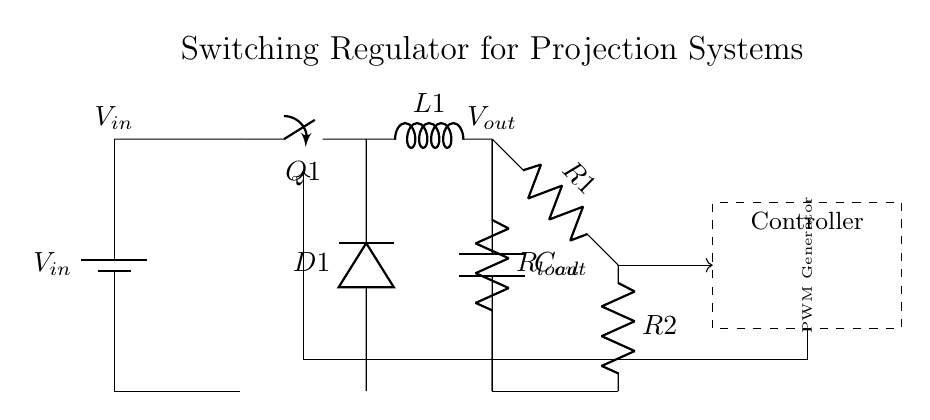What is the input voltage of the circuit? The input voltage is indicated as V_in at the top left of the diagram. It's typically connected to a battery or power supply which provides the voltage for the circuit.
Answer: V_in What type of switch is used in this circuit? The switch is labeled as Q1 in the diagram. Given the context of a switching regulator, it is typically a MOSFET or transistor used to control the flow of current through the inductor.
Answer: Q1 What component is responsible for smoothing the output voltage? The output capacitor is labeled C_out. It works by filtering the voltage ripple caused by switching, providing a steadier output voltage to the load.
Answer: C_out Explain the role of the inductor in this circuit. The inductor, labeled L1, stores energy when the switch Q1 is closed and releases energy to the load when the switch is open. This helps maintain a consistent output current and voltage despite load changes.
Answer: Energy storage What is the purpose of the feedback network in this regulator? The feedback network, consisting of resistors R1 and R2, is used to monitor the output voltage (V_out) and regulate it by providing a control signal to the controller. This way, the circuit can adjust the duty cycle of the switch to maintain a constant output voltage regardless of variations in input voltage or load.
Answer: Voltage regulation What type of component is D1 and why is it important? D1 is a diode. Its role is to prevent current from flowing back into the inductor when the switch is open, allowing current to flow only to the output capacitor and load, which is critical for the regulator's operation.
Answer: Diode How does the PWM Generator impact the efficiency of the regulator? The PWM Generator produces a control signal that adjusts the duty cycle of the switch Q1, allowing the circuit to efficiently manage power delivery to the load. By rapidly turning the switch on and off, it minimizes energy loss and improves overall efficiency.
Answer: Efficiency management 